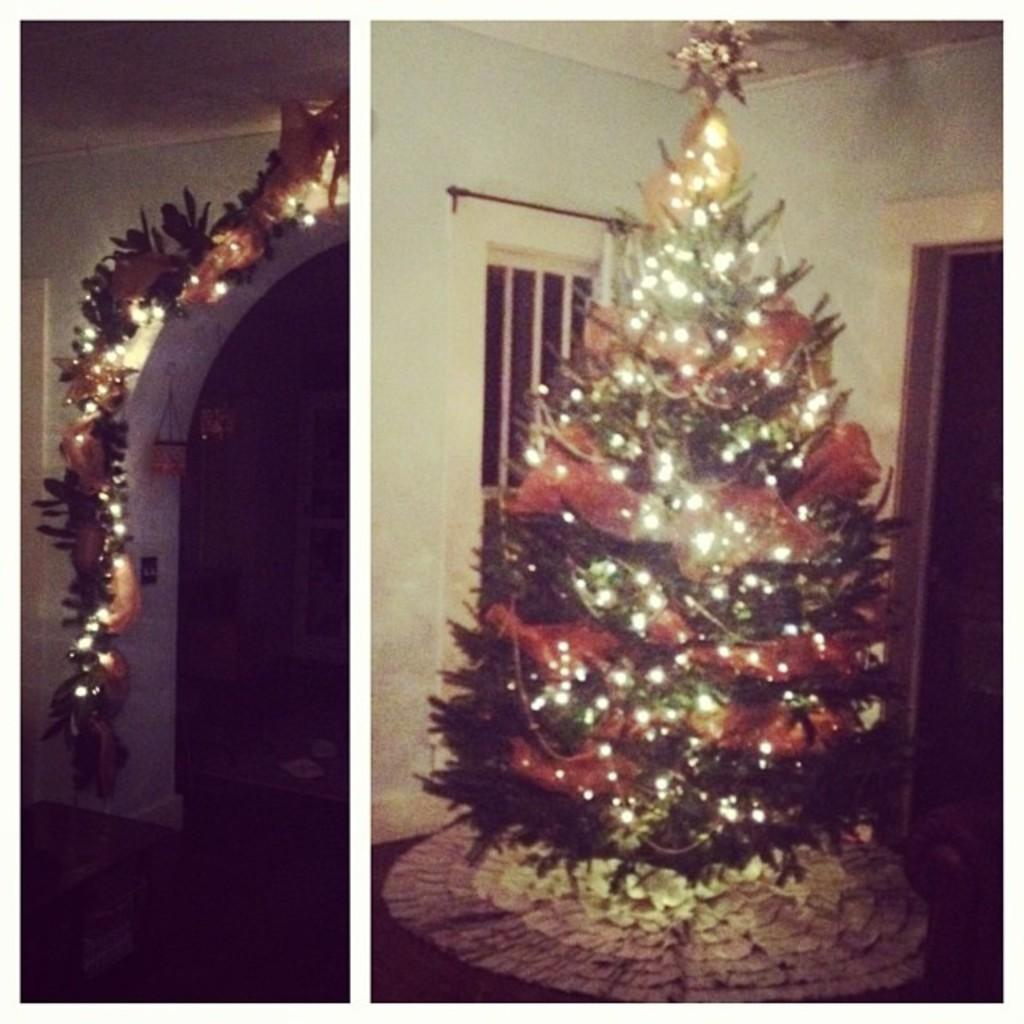What type of artwork is the image? The image is a collage. What is the main feature of the collage? There is a Christmas tree with lights in the image. What other items can be seen in the collage? Decorative items are present in the image, including an arch and a window. What type of objects are visible in the collage? There are various objects in the image, such as walls and other decorative items. How does the person in the image care for the plants? There is no person present in the image, and no plants are visible. What is the selection process for the items in the image? The image is a collage, so there is no selection process for the items in the image, as they have been intentionally chosen and arranged by the artist. 